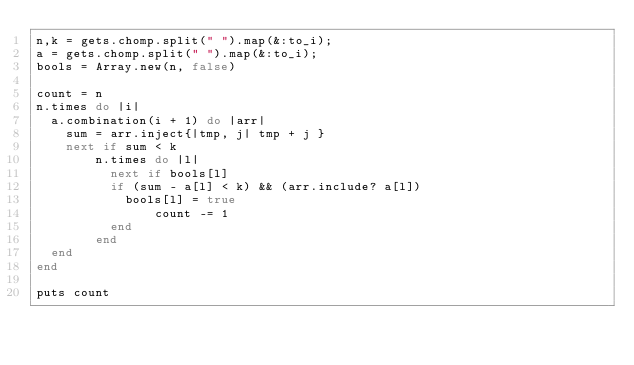Convert code to text. <code><loc_0><loc_0><loc_500><loc_500><_Ruby_>n,k = gets.chomp.split(" ").map(&:to_i);
a = gets.chomp.split(" ").map(&:to_i);
bools = Array.new(n, false)

count = n
n.times do |i|
  a.combination(i + 1) do |arr|
    sum = arr.inject{|tmp, j| tmp + j } 
    next if sum < k
        n.times do |l|
          next if bools[l]
          if (sum - a[l] < k) && (arr.include? a[l]) 
            bools[l] = true
                count -= 1
          end
        end
  end
end

puts count
</code> 